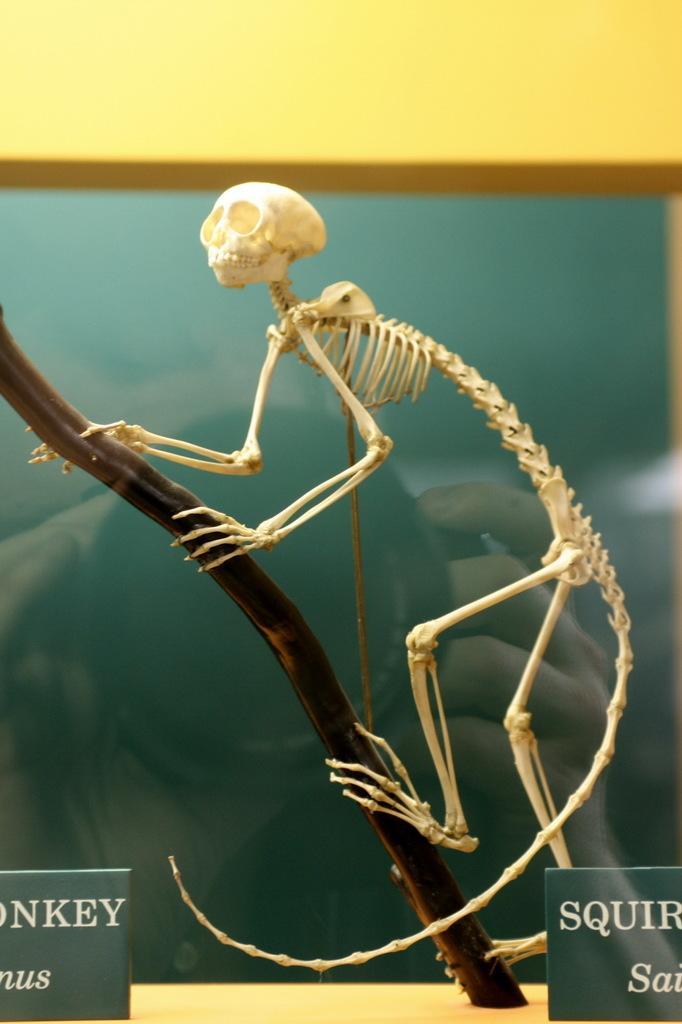Please provide a concise description of this image. In this picture we can see skeleton on wooden platform. In the bottom left and right side of the image we can see boards. In the background of the image we can see frame on the wall. 